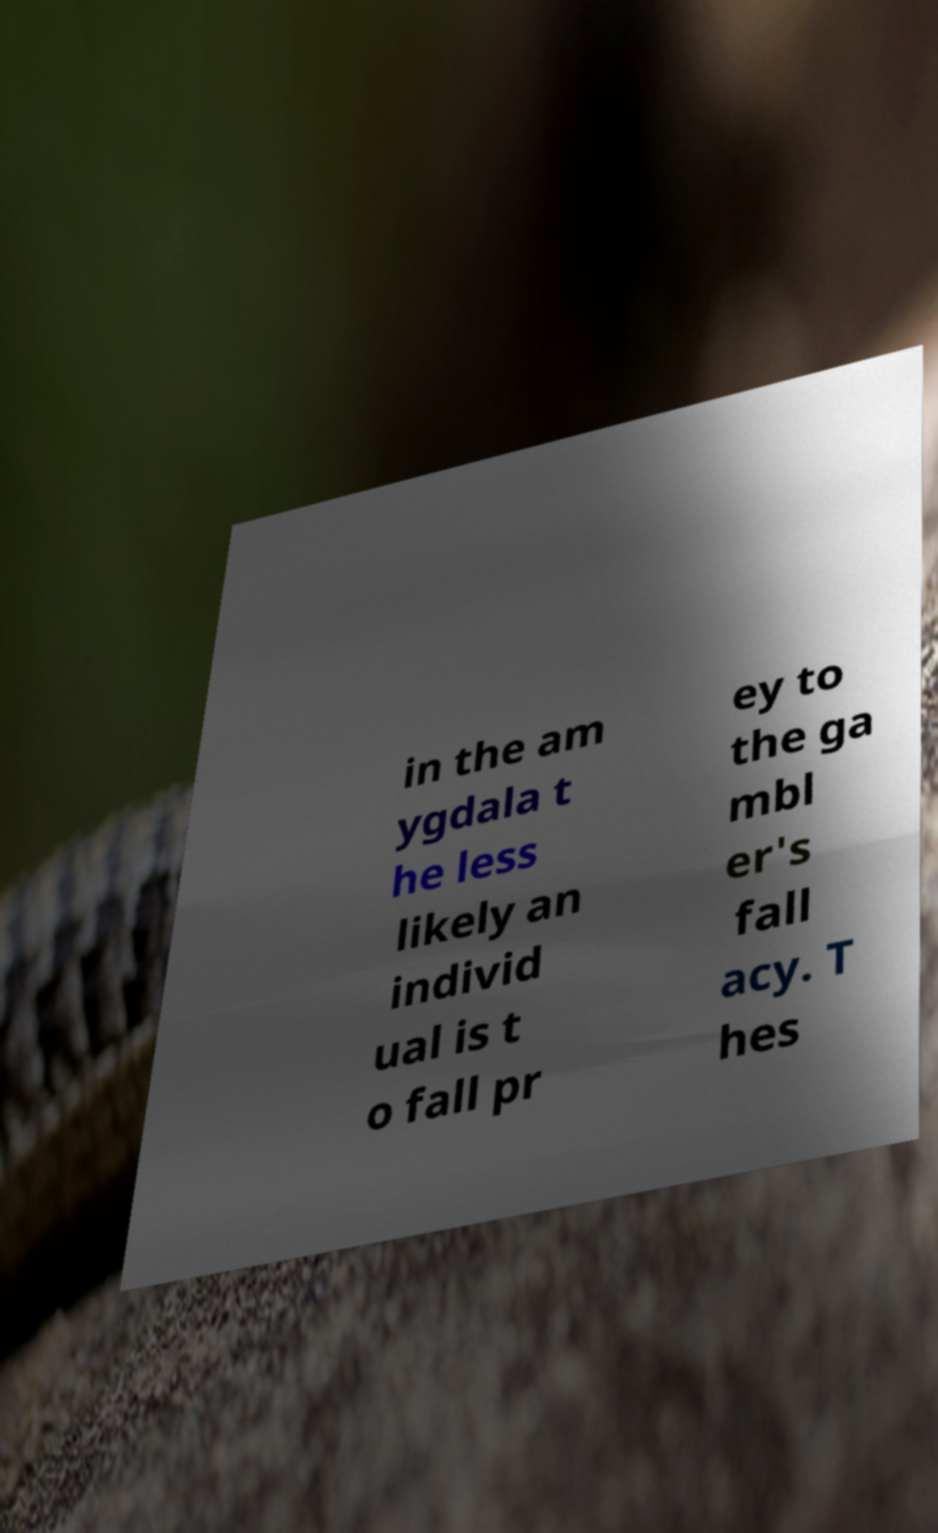Could you extract and type out the text from this image? in the am ygdala t he less likely an individ ual is t o fall pr ey to the ga mbl er's fall acy. T hes 